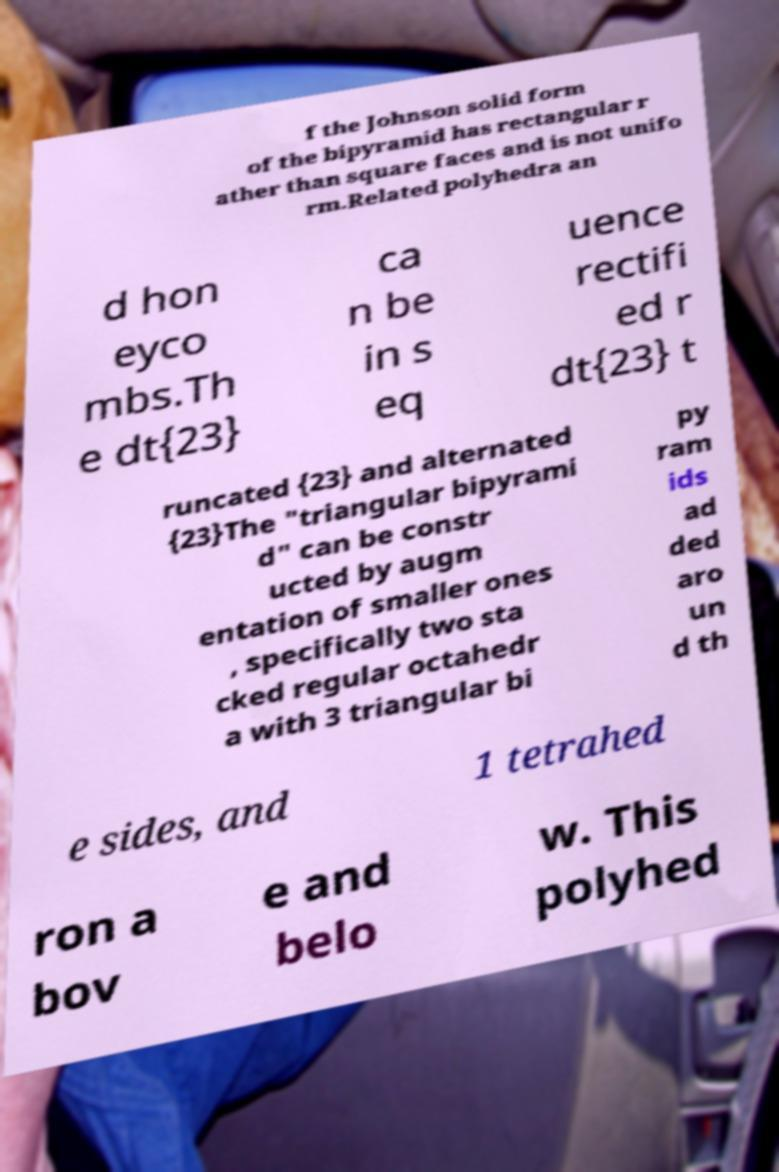Please read and relay the text visible in this image. What does it say? f the Johnson solid form of the bipyramid has rectangular r ather than square faces and is not unifo rm.Related polyhedra an d hon eyco mbs.Th e dt{23} ca n be in s eq uence rectifi ed r dt{23} t runcated {23} and alternated {23}The "triangular bipyrami d" can be constr ucted by augm entation of smaller ones , specifically two sta cked regular octahedr a with 3 triangular bi py ram ids ad ded aro un d th e sides, and 1 tetrahed ron a bov e and belo w. This polyhed 